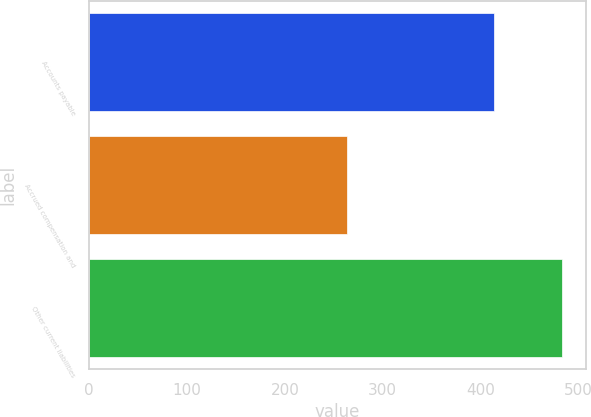Convert chart to OTSL. <chart><loc_0><loc_0><loc_500><loc_500><bar_chart><fcel>Accounts payable<fcel>Accrued compensation and<fcel>Other current liabilities<nl><fcel>414<fcel>263<fcel>483<nl></chart> 